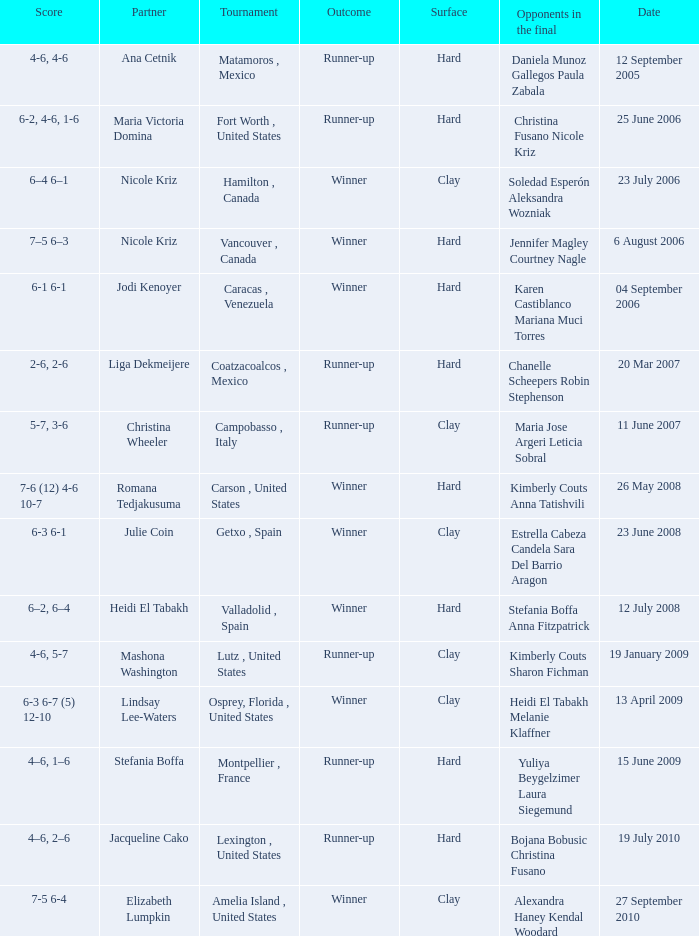What was the date for the match where Tweedie-Yates' partner was jodi kenoyer? 04 September 2006. 